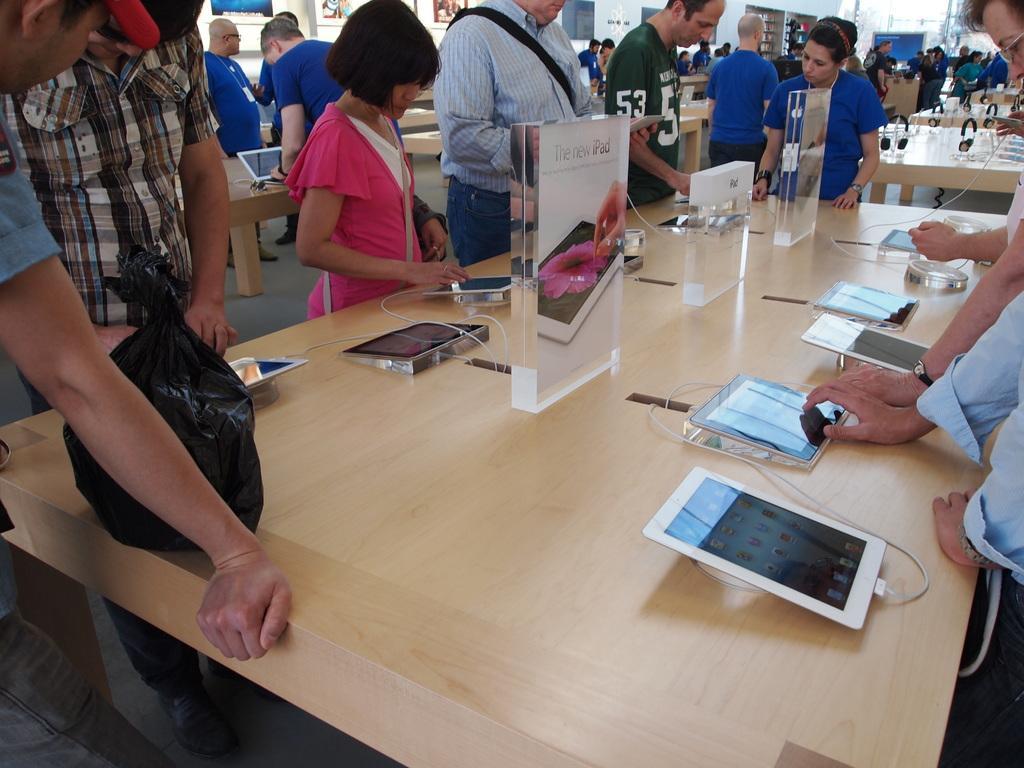Could you give a brief overview of what you see in this image? Group of people standing. We can see tables on the table we can see tabs,boards,cables. This is floor. 